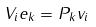Convert formula to latex. <formula><loc_0><loc_0><loc_500><loc_500>V _ { i } e _ { k } = P _ { k } v _ { i }</formula> 